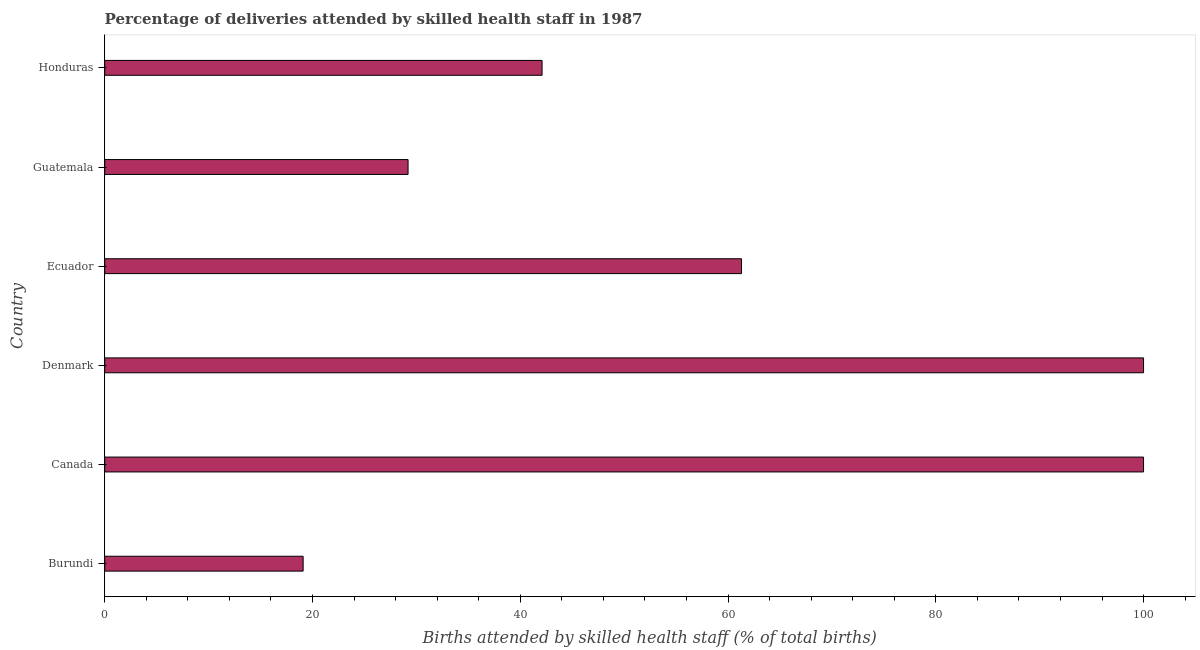Does the graph contain grids?
Make the answer very short. No. What is the title of the graph?
Your answer should be compact. Percentage of deliveries attended by skilled health staff in 1987. What is the label or title of the X-axis?
Offer a terse response. Births attended by skilled health staff (% of total births). What is the label or title of the Y-axis?
Keep it short and to the point. Country. What is the number of births attended by skilled health staff in Honduras?
Offer a very short reply. 42.1. Across all countries, what is the minimum number of births attended by skilled health staff?
Your answer should be very brief. 19.1. In which country was the number of births attended by skilled health staff maximum?
Your answer should be compact. Canada. In which country was the number of births attended by skilled health staff minimum?
Provide a short and direct response. Burundi. What is the sum of the number of births attended by skilled health staff?
Give a very brief answer. 351.7. What is the difference between the number of births attended by skilled health staff in Denmark and Honduras?
Provide a short and direct response. 57.9. What is the average number of births attended by skilled health staff per country?
Offer a very short reply. 58.62. What is the median number of births attended by skilled health staff?
Ensure brevity in your answer.  51.7. In how many countries, is the number of births attended by skilled health staff greater than 84 %?
Provide a short and direct response. 2. What is the ratio of the number of births attended by skilled health staff in Burundi to that in Honduras?
Your answer should be very brief. 0.45. Is the number of births attended by skilled health staff in Ecuador less than that in Guatemala?
Provide a short and direct response. No. Is the sum of the number of births attended by skilled health staff in Canada and Denmark greater than the maximum number of births attended by skilled health staff across all countries?
Offer a very short reply. Yes. What is the difference between the highest and the lowest number of births attended by skilled health staff?
Make the answer very short. 80.9. In how many countries, is the number of births attended by skilled health staff greater than the average number of births attended by skilled health staff taken over all countries?
Give a very brief answer. 3. How many countries are there in the graph?
Your answer should be compact. 6. What is the difference between two consecutive major ticks on the X-axis?
Make the answer very short. 20. Are the values on the major ticks of X-axis written in scientific E-notation?
Your answer should be very brief. No. What is the Births attended by skilled health staff (% of total births) of Canada?
Provide a short and direct response. 100. What is the Births attended by skilled health staff (% of total births) of Ecuador?
Keep it short and to the point. 61.3. What is the Births attended by skilled health staff (% of total births) of Guatemala?
Offer a very short reply. 29.2. What is the Births attended by skilled health staff (% of total births) of Honduras?
Provide a succinct answer. 42.1. What is the difference between the Births attended by skilled health staff (% of total births) in Burundi and Canada?
Make the answer very short. -80.9. What is the difference between the Births attended by skilled health staff (% of total births) in Burundi and Denmark?
Make the answer very short. -80.9. What is the difference between the Births attended by skilled health staff (% of total births) in Burundi and Ecuador?
Ensure brevity in your answer.  -42.2. What is the difference between the Births attended by skilled health staff (% of total births) in Burundi and Guatemala?
Your answer should be very brief. -10.1. What is the difference between the Births attended by skilled health staff (% of total births) in Canada and Ecuador?
Keep it short and to the point. 38.7. What is the difference between the Births attended by skilled health staff (% of total births) in Canada and Guatemala?
Keep it short and to the point. 70.8. What is the difference between the Births attended by skilled health staff (% of total births) in Canada and Honduras?
Your answer should be compact. 57.9. What is the difference between the Births attended by skilled health staff (% of total births) in Denmark and Ecuador?
Make the answer very short. 38.7. What is the difference between the Births attended by skilled health staff (% of total births) in Denmark and Guatemala?
Provide a short and direct response. 70.8. What is the difference between the Births attended by skilled health staff (% of total births) in Denmark and Honduras?
Keep it short and to the point. 57.9. What is the difference between the Births attended by skilled health staff (% of total births) in Ecuador and Guatemala?
Your answer should be compact. 32.1. What is the ratio of the Births attended by skilled health staff (% of total births) in Burundi to that in Canada?
Your response must be concise. 0.19. What is the ratio of the Births attended by skilled health staff (% of total births) in Burundi to that in Denmark?
Provide a short and direct response. 0.19. What is the ratio of the Births attended by skilled health staff (% of total births) in Burundi to that in Ecuador?
Make the answer very short. 0.31. What is the ratio of the Births attended by skilled health staff (% of total births) in Burundi to that in Guatemala?
Your response must be concise. 0.65. What is the ratio of the Births attended by skilled health staff (% of total births) in Burundi to that in Honduras?
Keep it short and to the point. 0.45. What is the ratio of the Births attended by skilled health staff (% of total births) in Canada to that in Denmark?
Your answer should be compact. 1. What is the ratio of the Births attended by skilled health staff (% of total births) in Canada to that in Ecuador?
Provide a succinct answer. 1.63. What is the ratio of the Births attended by skilled health staff (% of total births) in Canada to that in Guatemala?
Give a very brief answer. 3.42. What is the ratio of the Births attended by skilled health staff (% of total births) in Canada to that in Honduras?
Your answer should be compact. 2.38. What is the ratio of the Births attended by skilled health staff (% of total births) in Denmark to that in Ecuador?
Your response must be concise. 1.63. What is the ratio of the Births attended by skilled health staff (% of total births) in Denmark to that in Guatemala?
Offer a very short reply. 3.42. What is the ratio of the Births attended by skilled health staff (% of total births) in Denmark to that in Honduras?
Provide a succinct answer. 2.38. What is the ratio of the Births attended by skilled health staff (% of total births) in Ecuador to that in Guatemala?
Your answer should be very brief. 2.1. What is the ratio of the Births attended by skilled health staff (% of total births) in Ecuador to that in Honduras?
Provide a short and direct response. 1.46. What is the ratio of the Births attended by skilled health staff (% of total births) in Guatemala to that in Honduras?
Provide a short and direct response. 0.69. 